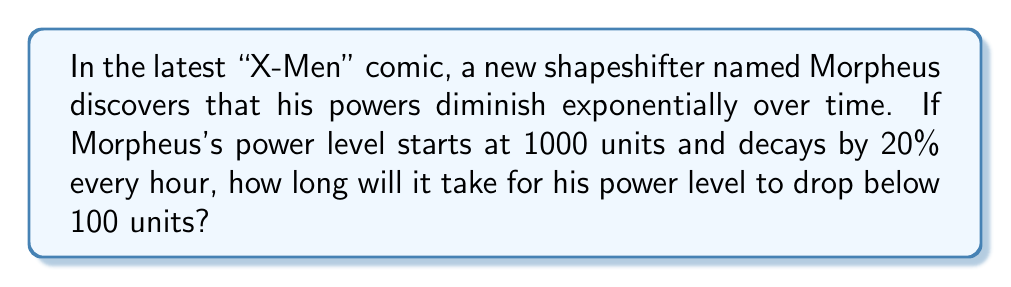Teach me how to tackle this problem. Let's approach this step-by-step using the exponential decay formula:

1) The exponential decay formula is:
   $A(t) = A_0 \cdot (1-r)^t$

   Where:
   $A(t)$ is the amount at time $t$
   $A_0$ is the initial amount
   $r$ is the decay rate per unit time
   $t$ is the time

2) We know:
   $A_0 = 1000$ (initial power level)
   $r = 0.20$ (20% decay rate)
   $A(t) = 100$ (we want to find when it drops below this)

3) Plugging into the formula:
   $100 = 1000 \cdot (1-0.20)^t$

4) Simplify:
   $100 = 1000 \cdot (0.8)^t$

5) Divide both sides by 1000:
   $0.1 = (0.8)^t$

6) Take the natural log of both sides:
   $\ln(0.1) = \ln((0.8)^t)$

7) Use the logarithm property $\ln(a^b) = b\ln(a)$:
   $\ln(0.1) = t \cdot \ln(0.8)$

8) Solve for $t$:
   $t = \frac{\ln(0.1)}{\ln(0.8)} \approx 10.32$ hours

Therefore, it will take approximately 10.32 hours for Morpheus's power level to drop below 100 units.
Answer: 10.32 hours 